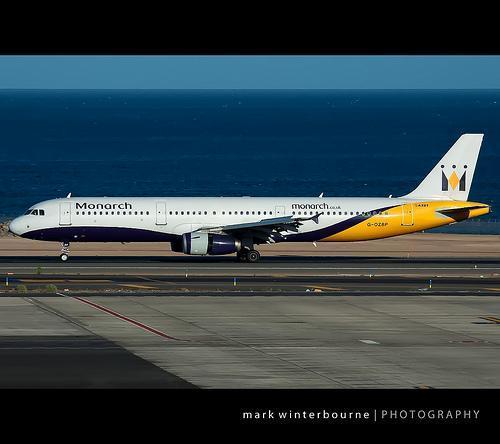How many circles are on the planes tail?
Give a very brief answer. 3. 